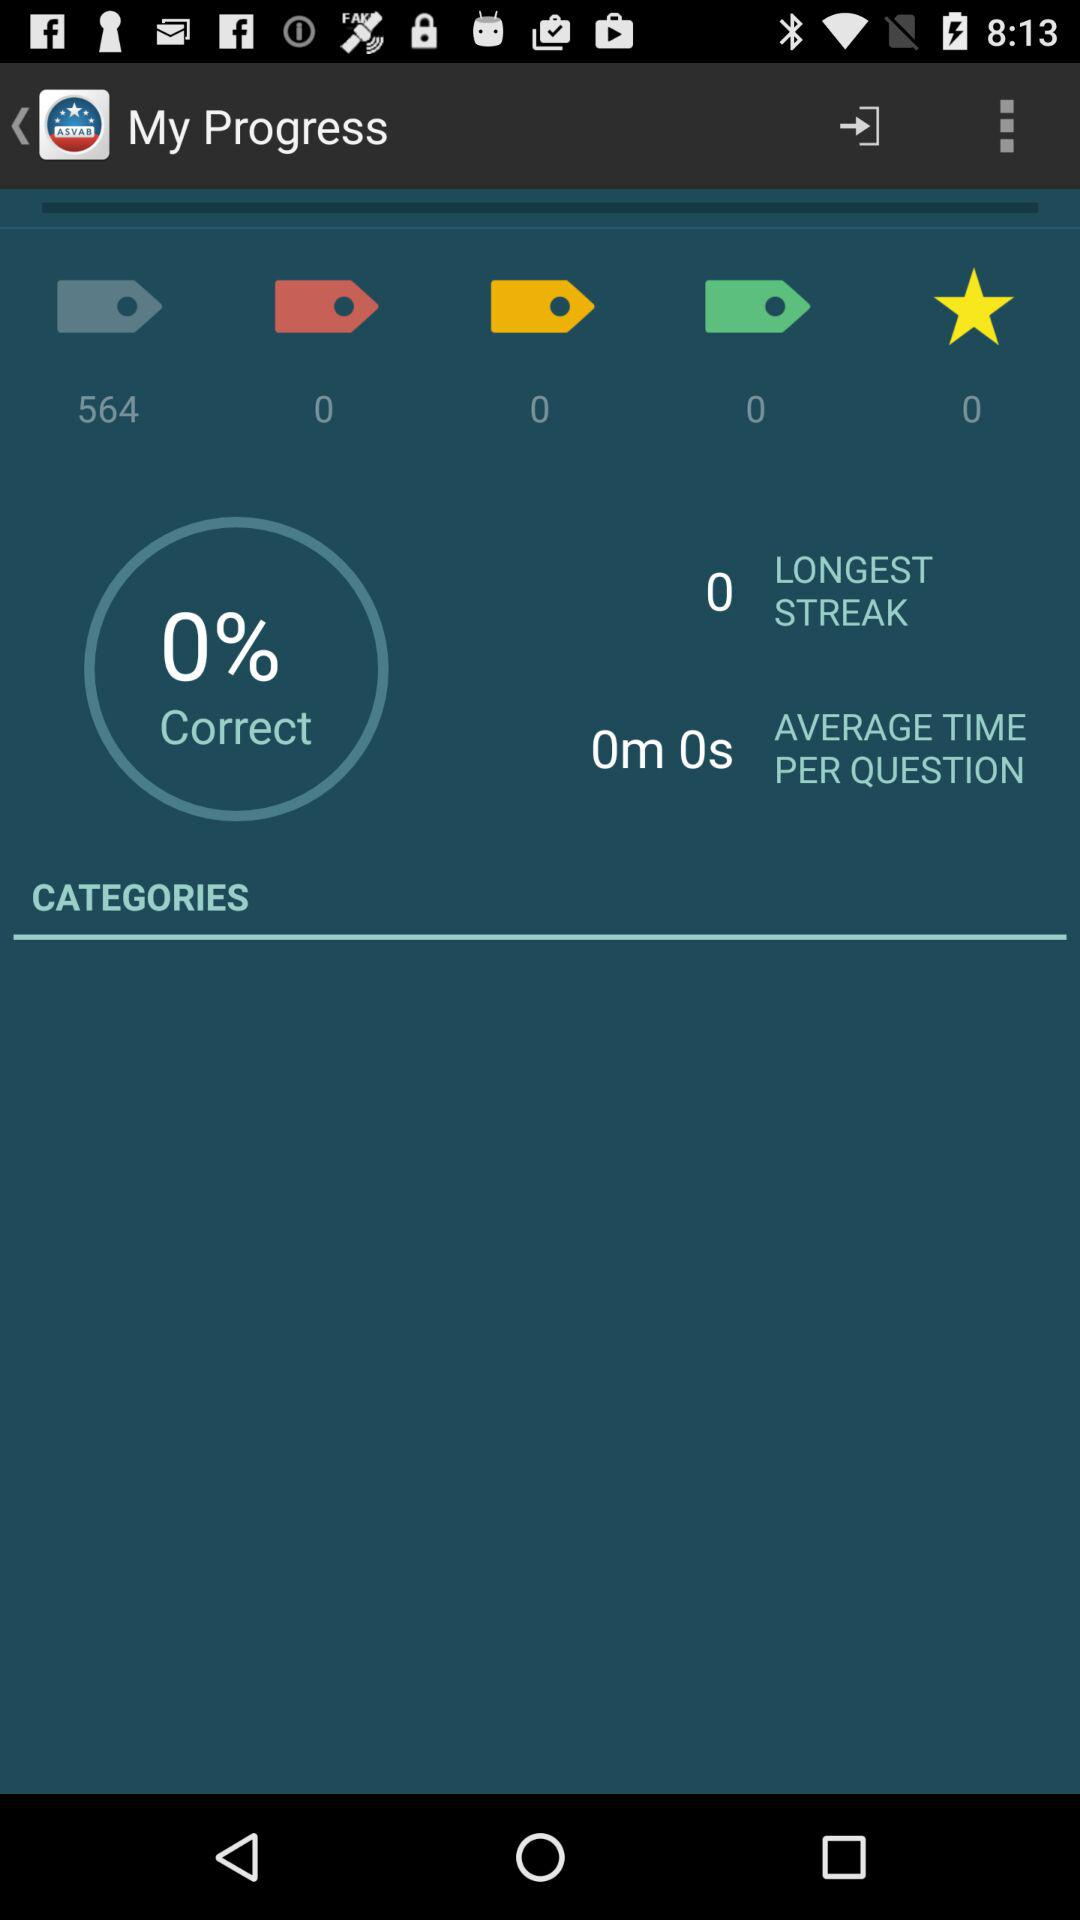What is the longest streak? The longest streak is 0. 